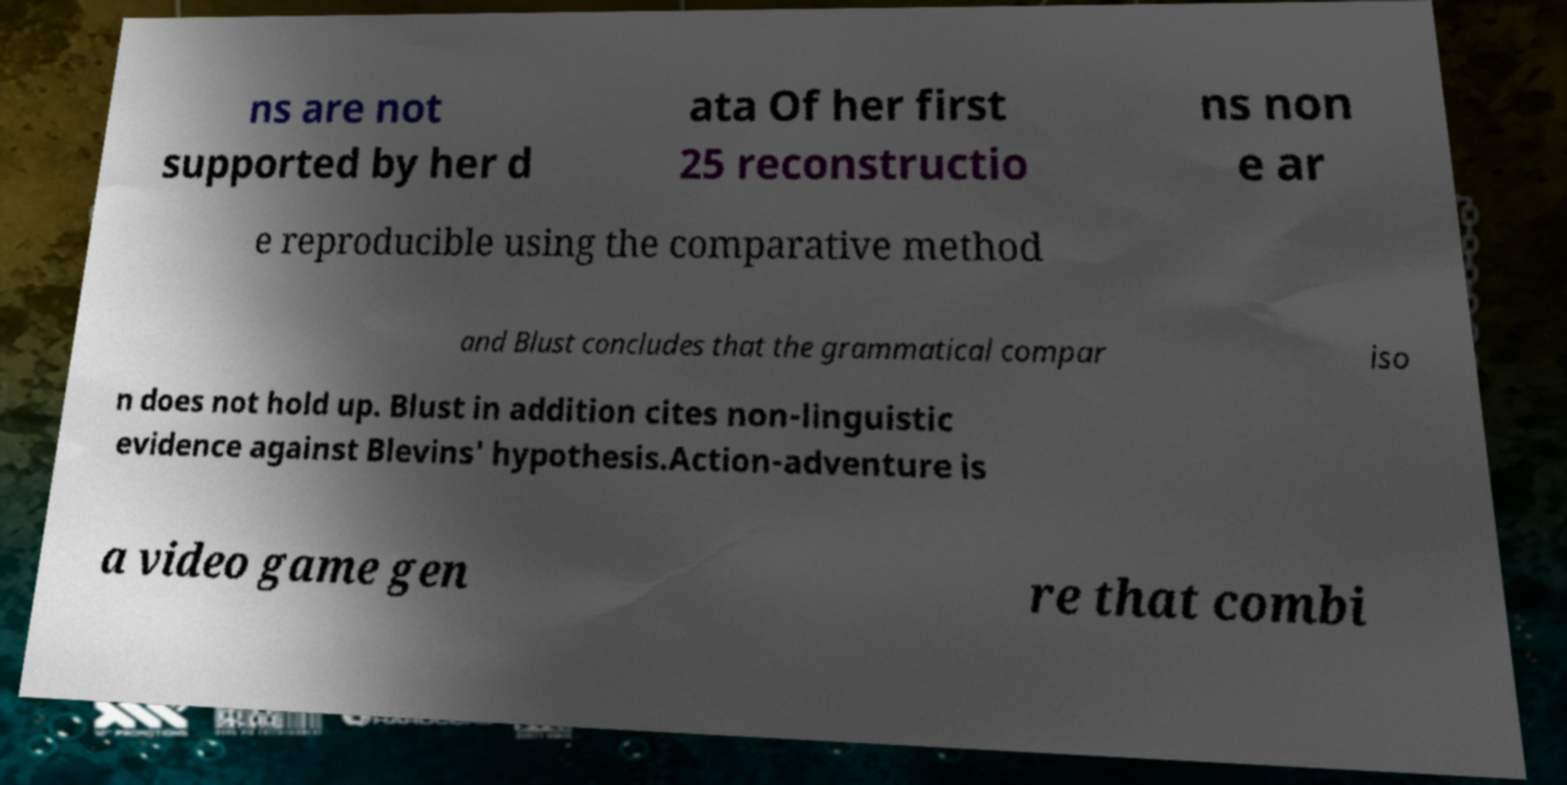Could you assist in decoding the text presented in this image and type it out clearly? ns are not supported by her d ata Of her first 25 reconstructio ns non e ar e reproducible using the comparative method and Blust concludes that the grammatical compar iso n does not hold up. Blust in addition cites non-linguistic evidence against Blevins' hypothesis.Action-adventure is a video game gen re that combi 